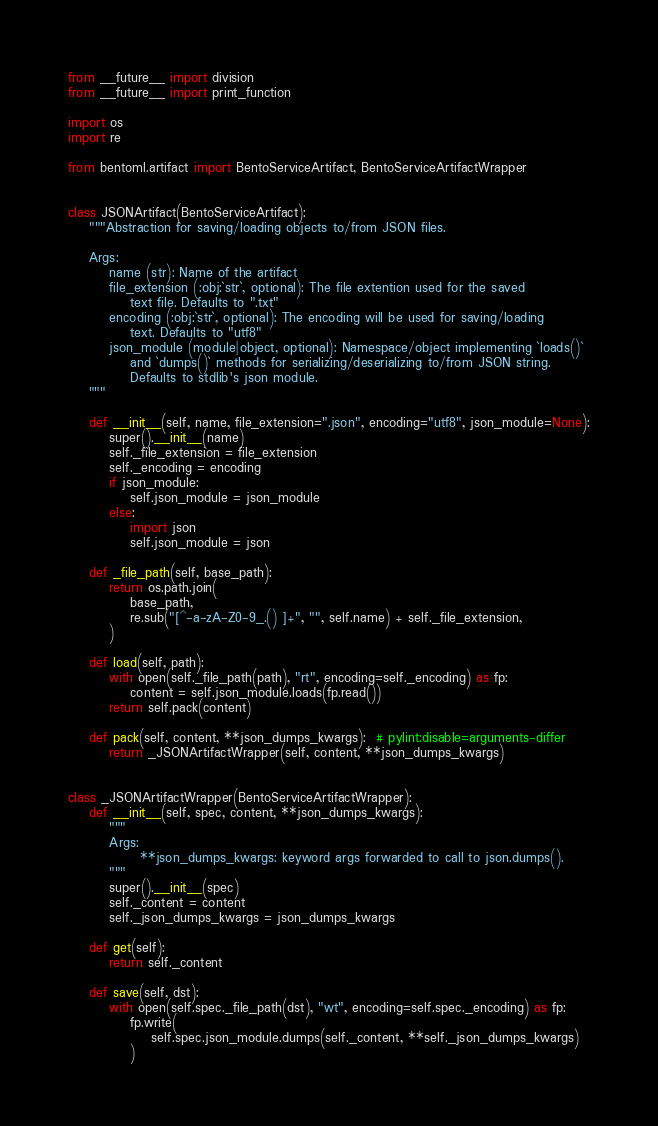Convert code to text. <code><loc_0><loc_0><loc_500><loc_500><_Python_>from __future__ import division
from __future__ import print_function

import os
import re

from bentoml.artifact import BentoServiceArtifact, BentoServiceArtifactWrapper


class JSONArtifact(BentoServiceArtifact):
    """Abstraction for saving/loading objects to/from JSON files.

    Args:
        name (str): Name of the artifact
        file_extension (:obj:`str`, optional): The file extention used for the saved
            text file. Defaults to ".txt"
        encoding (:obj:`str`, optional): The encoding will be used for saving/loading
            text. Defaults to "utf8"
        json_module (module|object, optional): Namespace/object implementing `loads()`
            and `dumps()` methods for serializing/deserializing to/from JSON string.
            Defaults to stdlib's json module.
    """

    def __init__(self, name, file_extension=".json", encoding="utf8", json_module=None):
        super().__init__(name)
        self._file_extension = file_extension
        self._encoding = encoding
        if json_module:
            self.json_module = json_module
        else:
            import json
            self.json_module = json

    def _file_path(self, base_path):
        return os.path.join(
            base_path,
            re.sub("[^-a-zA-Z0-9_.() ]+", "", self.name) + self._file_extension,
        )

    def load(self, path):
        with open(self._file_path(path), "rt", encoding=self._encoding) as fp:
            content = self.json_module.loads(fp.read())
        return self.pack(content)

    def pack(self, content, **json_dumps_kwargs):  # pylint:disable=arguments-differ
        return _JSONArtifactWrapper(self, content, **json_dumps_kwargs)


class _JSONArtifactWrapper(BentoServiceArtifactWrapper):
    def __init__(self, spec, content, **json_dumps_kwargs):
        """
        Args:
              **json_dumps_kwargs: keyword args forwarded to call to json.dumps().
        """
        super().__init__(spec)
        self._content = content
        self._json_dumps_kwargs = json_dumps_kwargs

    def get(self):
        return self._content

    def save(self, dst):
        with open(self.spec._file_path(dst), "wt", encoding=self.spec._encoding) as fp:
            fp.write(
                self.spec.json_module.dumps(self._content, **self._json_dumps_kwargs)
            )
</code> 